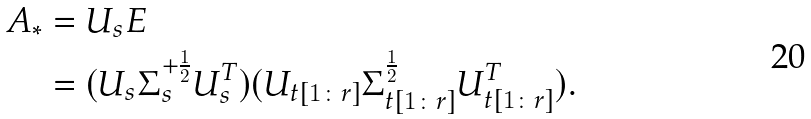<formula> <loc_0><loc_0><loc_500><loc_500>A _ { \ast } & = U _ { s } E \\ & = ( U _ { s } \Sigma _ { s } ^ { + \frac { 1 } { 2 } } U _ { s } ^ { T } ) ( U _ { t [ 1 \colon r ] } \Sigma _ { t [ 1 \colon r ] } ^ { \frac { 1 } { 2 } } U _ { t [ 1 \colon r ] } ^ { T } ) .</formula> 